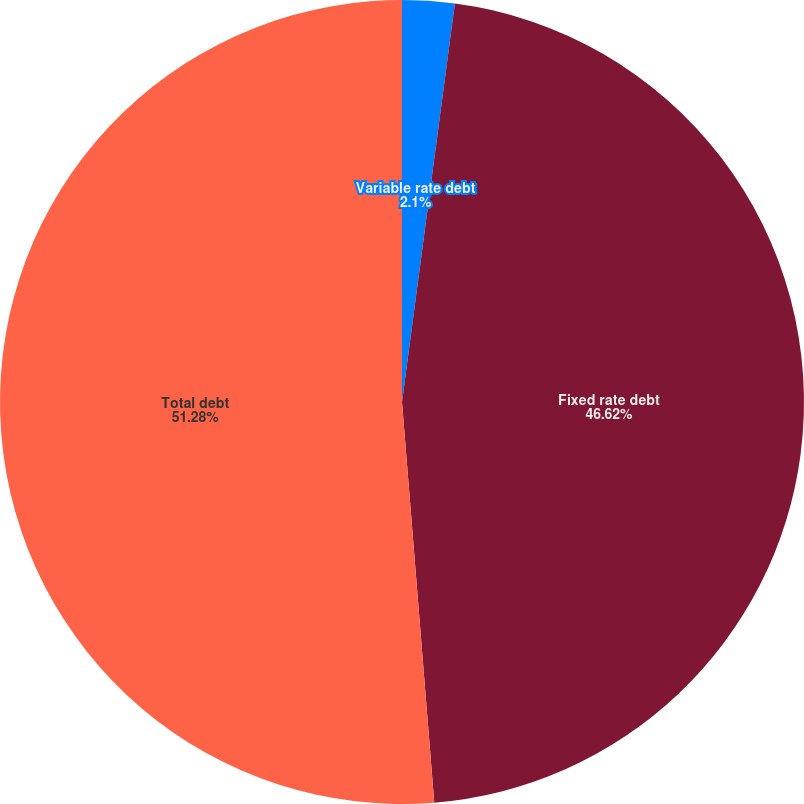<chart> <loc_0><loc_0><loc_500><loc_500><pie_chart><fcel>Variable rate debt<fcel>Fixed rate debt<fcel>Total debt<nl><fcel>2.1%<fcel>46.62%<fcel>51.28%<nl></chart> 